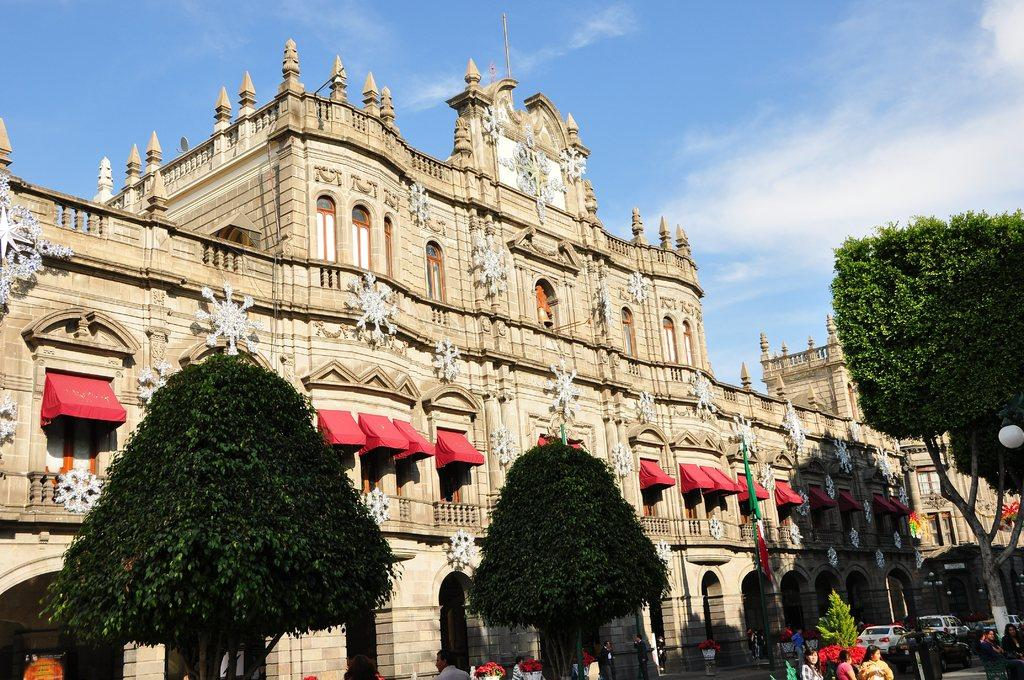What type of structures can be seen in the image? There are buildings in the image. What are the flags associated with in the image? The flags are associated with the buildings in the image. What are the persons in the image doing? The persons are standing on the road in the image. What type of vehicles can be seen in the image? Motor vehicles are visible in the image. What type of vegetation is present in the image? There are trees in the image. What type of lighting is present on the road in the image? Street lights are present in the image. What additional decorations are visible in the image? Decorations are visible in the image. What is visible in the background of the image? The sky is visible in the image. What can be observed in the sky in the image? Clouds are present in the sky. What theory is being discussed by the persons standing on the road in the image? There is no indication in the image that the persons are discussing any theory. Can you hear the persons laughing in the image? The image is silent, so it is not possible to hear any laughter. 